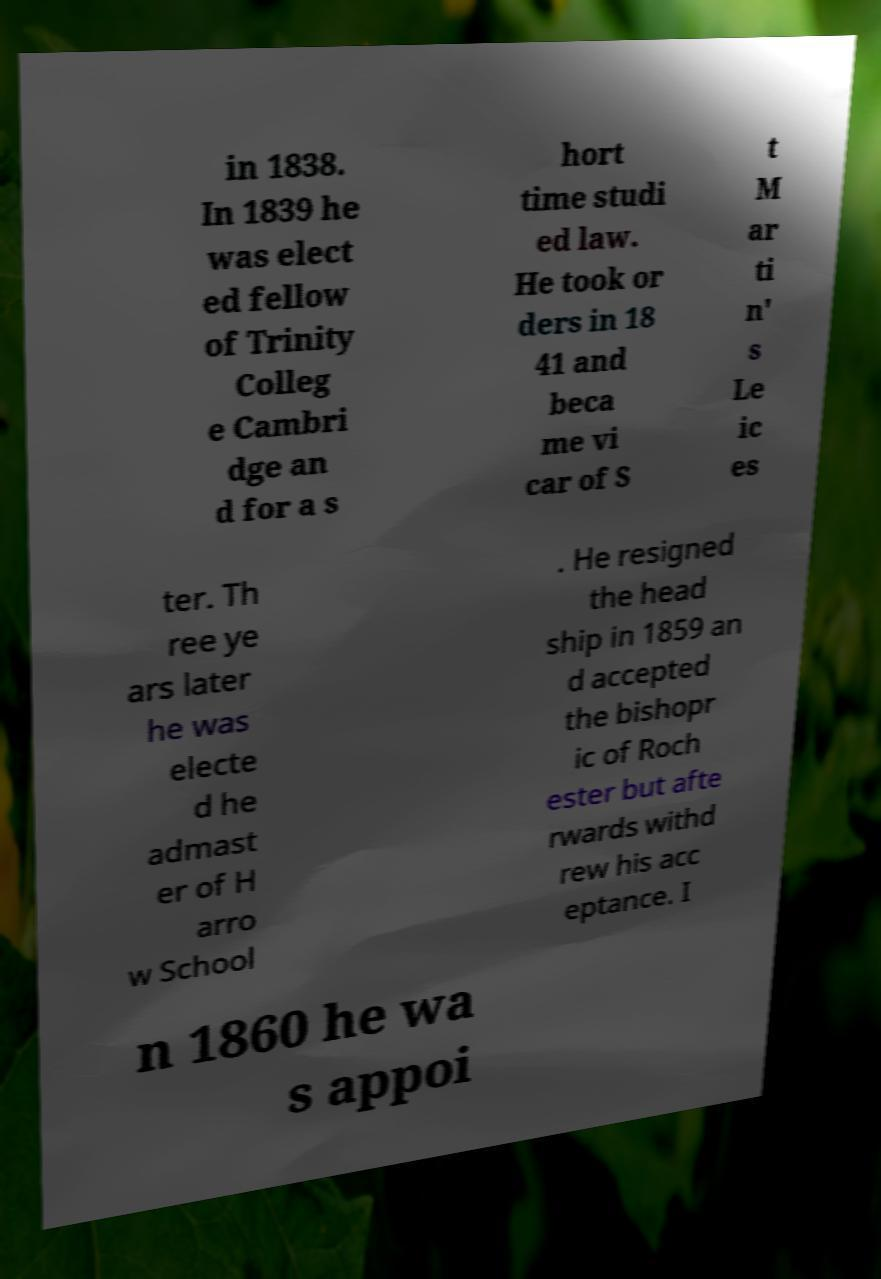Please read and relay the text visible in this image. What does it say? in 1838. In 1839 he was elect ed fellow of Trinity Colleg e Cambri dge an d for a s hort time studi ed law. He took or ders in 18 41 and beca me vi car of S t M ar ti n' s Le ic es ter. Th ree ye ars later he was electe d he admast er of H arro w School . He resigned the head ship in 1859 an d accepted the bishopr ic of Roch ester but afte rwards withd rew his acc eptance. I n 1860 he wa s appoi 